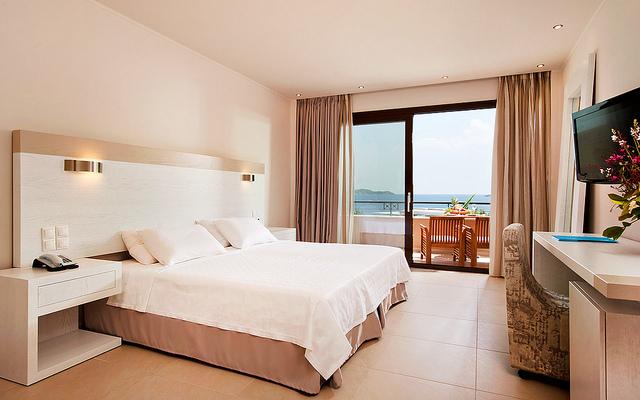How many chairs are in the room?
Short answer required. 1. How many pillows are on the bed?
Give a very brief answer. 4. Is this a vacation place?
Give a very brief answer. Yes. What color is the middle pillow?
Answer briefly. White. Are the chairs brown?
Quick response, please. Yes. Is that the front door?
Be succinct. No. Are there any lights on?
Answer briefly. Yes. Is this likely a professional photograph?
Write a very short answer. Yes. What type of people live in this room?
Write a very short answer. Vacationers. How many laptops are in the bedroom?
Give a very brief answer. 0. 